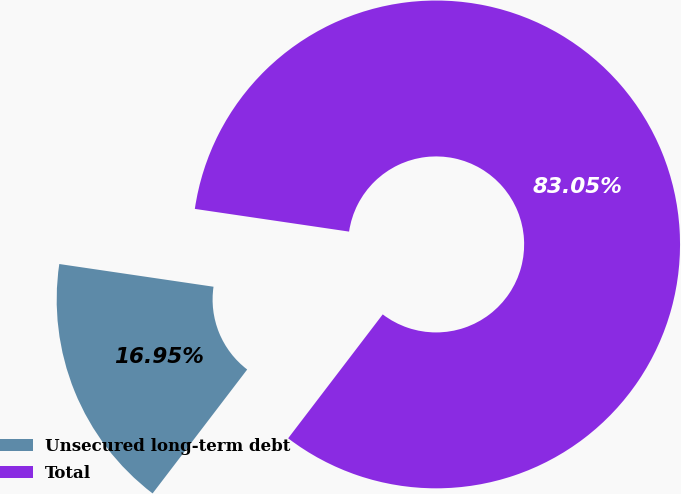<chart> <loc_0><loc_0><loc_500><loc_500><pie_chart><fcel>Unsecured long-term debt<fcel>Total<nl><fcel>16.95%<fcel>83.05%<nl></chart> 